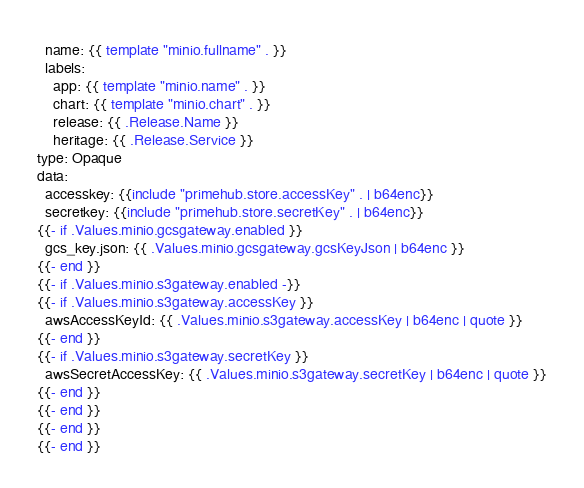<code> <loc_0><loc_0><loc_500><loc_500><_YAML_>  name: {{ template "minio.fullname" . }}
  labels:
    app: {{ template "minio.name" . }}
    chart: {{ template "minio.chart" . }}
    release: {{ .Release.Name }}
    heritage: {{ .Release.Service }}
type: Opaque
data:
  accesskey: {{include "primehub.store.accessKey" . | b64enc}}
  secretkey: {{include "primehub.store.secretKey" . | b64enc}}
{{- if .Values.minio.gcsgateway.enabled }}
  gcs_key.json: {{ .Values.minio.gcsgateway.gcsKeyJson | b64enc }}
{{- end }}
{{- if .Values.minio.s3gateway.enabled -}}
{{- if .Values.minio.s3gateway.accessKey }}
  awsAccessKeyId: {{ .Values.minio.s3gateway.accessKey | b64enc | quote }}
{{- end }}
{{- if .Values.minio.s3gateway.secretKey }}
  awsSecretAccessKey: {{ .Values.minio.s3gateway.secretKey | b64enc | quote }}
{{- end }}
{{- end }}
{{- end }}
{{- end }}
</code> 